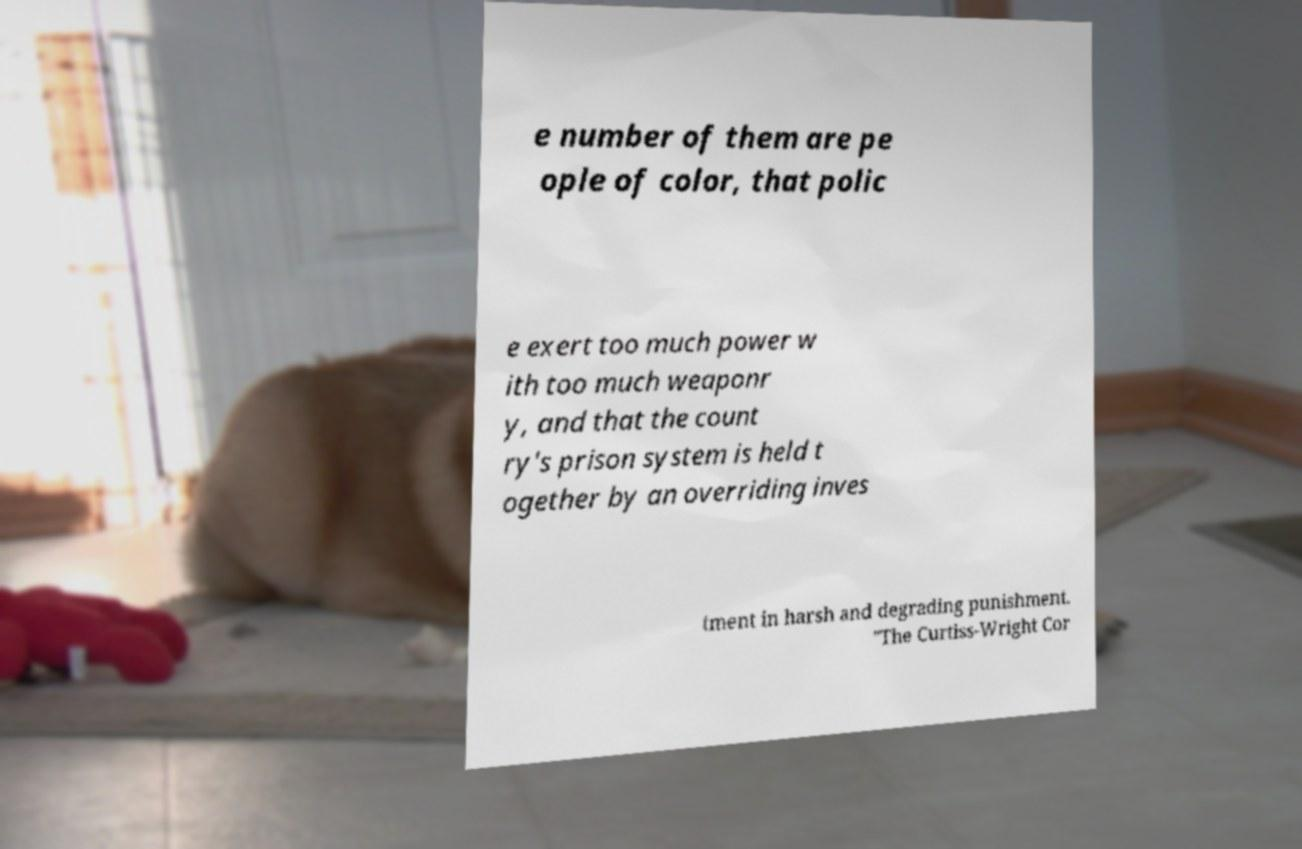There's text embedded in this image that I need extracted. Can you transcribe it verbatim? e number of them are pe ople of color, that polic e exert too much power w ith too much weaponr y, and that the count ry's prison system is held t ogether by an overriding inves tment in harsh and degrading punishment. "The Curtiss-Wright Cor 